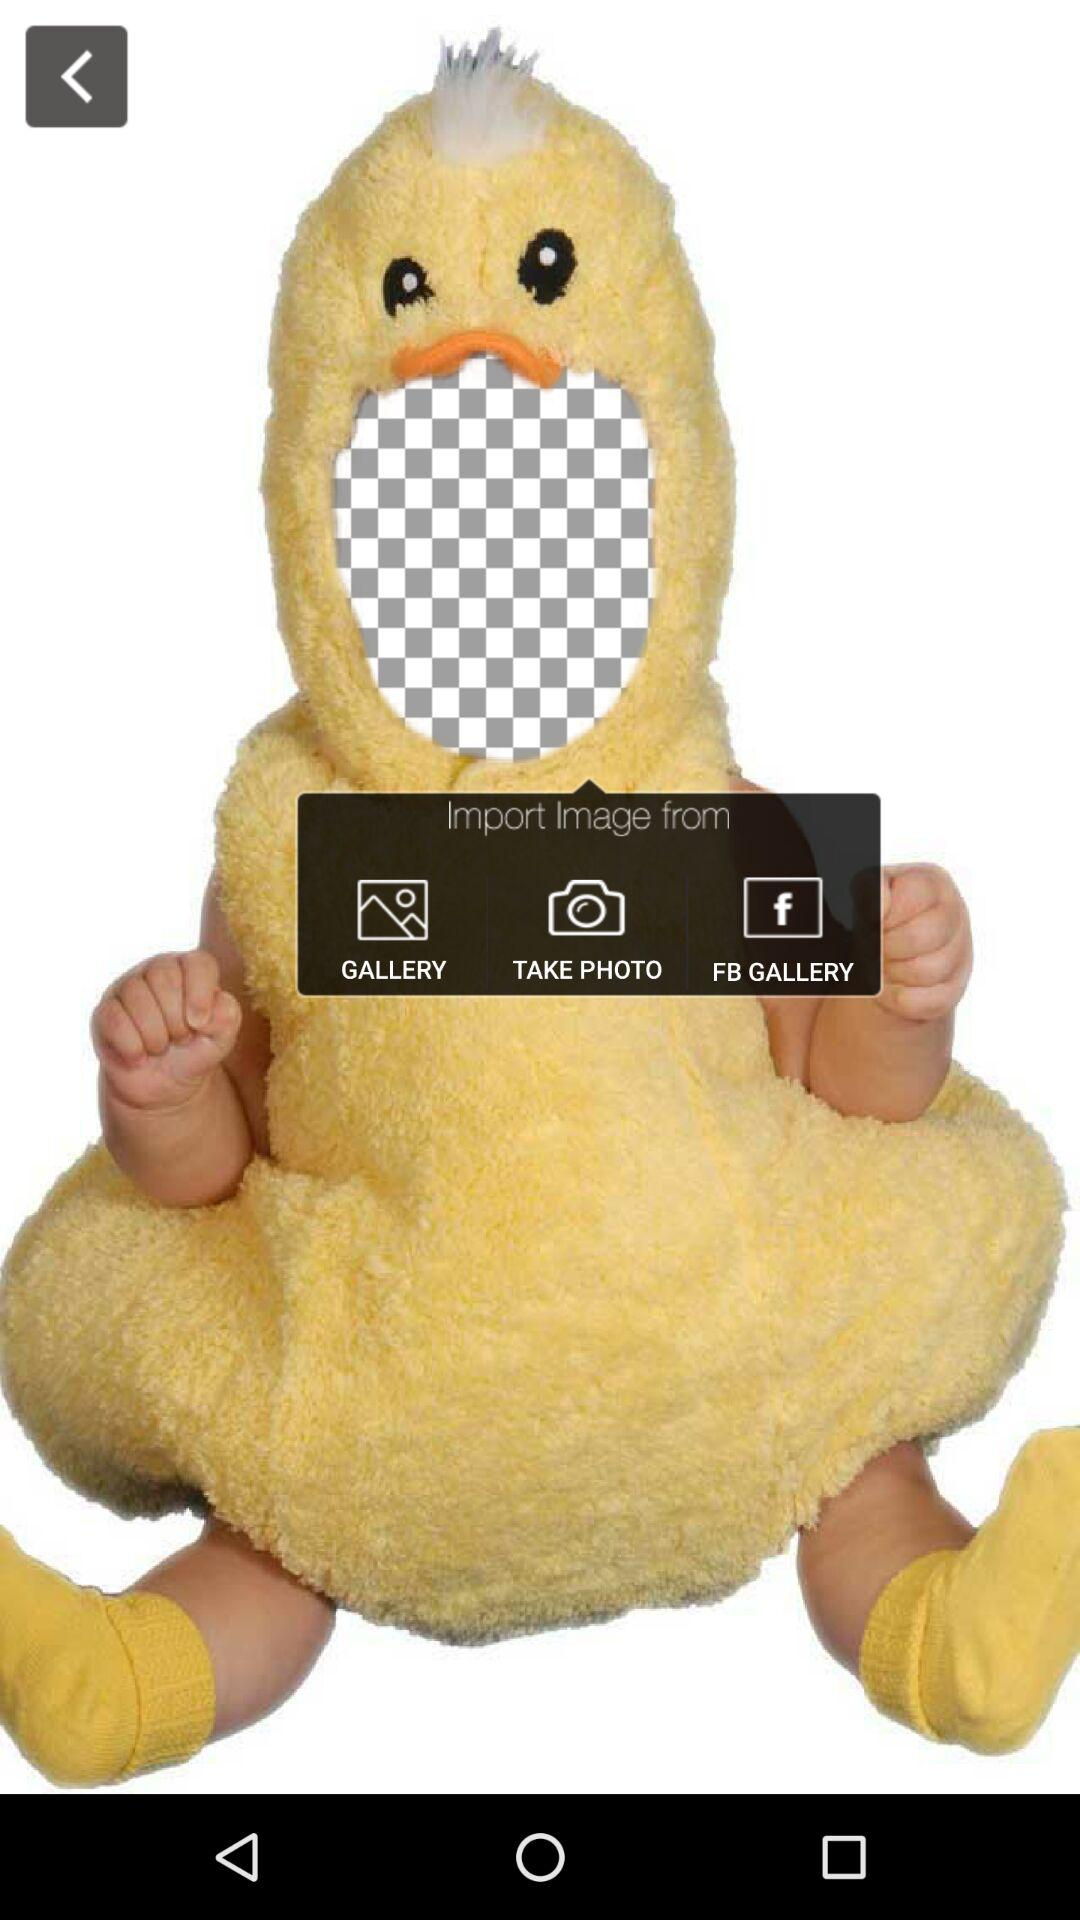From where the image can be imported? You can import images from "GALLERY", "TAKE PHOTO" and "FB GALLERY". 